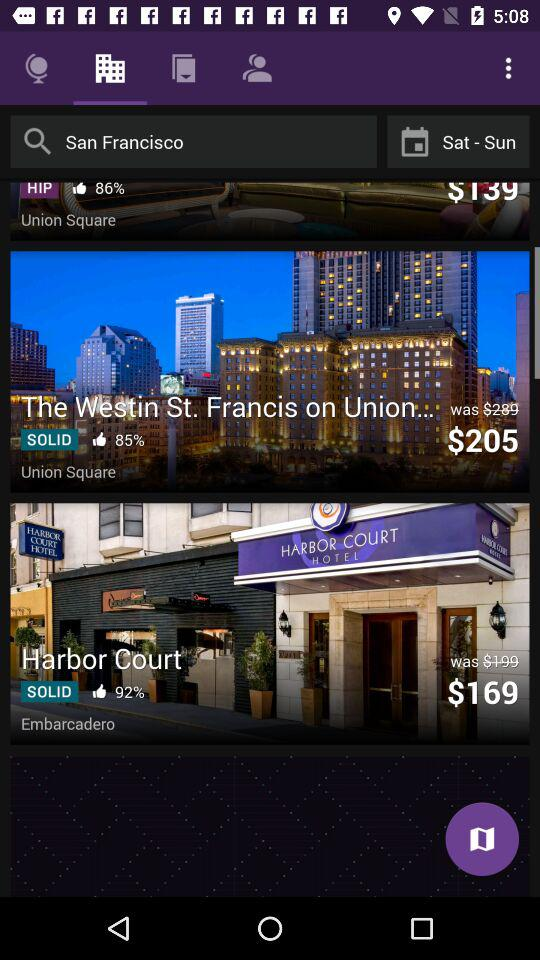What are the selected days? The selected days are Saturday and Sunday. 